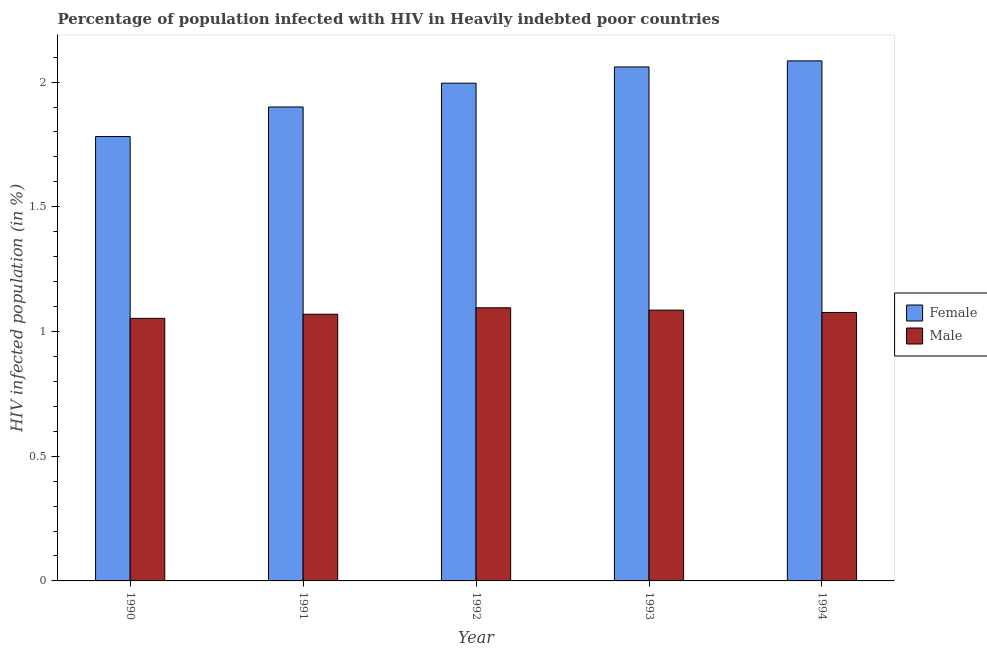How many different coloured bars are there?
Offer a terse response. 2. How many groups of bars are there?
Your response must be concise. 5. How many bars are there on the 1st tick from the left?
Your answer should be very brief. 2. What is the percentage of females who are infected with hiv in 1994?
Offer a terse response. 2.09. Across all years, what is the maximum percentage of males who are infected with hiv?
Your response must be concise. 1.1. Across all years, what is the minimum percentage of males who are infected with hiv?
Keep it short and to the point. 1.05. What is the total percentage of females who are infected with hiv in the graph?
Provide a succinct answer. 9.82. What is the difference between the percentage of males who are infected with hiv in 1991 and that in 1993?
Offer a terse response. -0.02. What is the difference between the percentage of males who are infected with hiv in 1992 and the percentage of females who are infected with hiv in 1994?
Your answer should be very brief. 0.02. What is the average percentage of females who are infected with hiv per year?
Your response must be concise. 1.96. In the year 1993, what is the difference between the percentage of females who are infected with hiv and percentage of males who are infected with hiv?
Provide a short and direct response. 0. In how many years, is the percentage of males who are infected with hiv greater than 1.9 %?
Your answer should be compact. 0. What is the ratio of the percentage of females who are infected with hiv in 1991 to that in 1992?
Ensure brevity in your answer.  0.95. Is the difference between the percentage of males who are infected with hiv in 1991 and 1993 greater than the difference between the percentage of females who are infected with hiv in 1991 and 1993?
Ensure brevity in your answer.  No. What is the difference between the highest and the second highest percentage of males who are infected with hiv?
Provide a succinct answer. 0.01. What is the difference between the highest and the lowest percentage of males who are infected with hiv?
Offer a terse response. 0.04. In how many years, is the percentage of males who are infected with hiv greater than the average percentage of males who are infected with hiv taken over all years?
Keep it short and to the point. 3. Is the sum of the percentage of males who are infected with hiv in 1993 and 1994 greater than the maximum percentage of females who are infected with hiv across all years?
Keep it short and to the point. Yes. What does the 2nd bar from the right in 1992 represents?
Give a very brief answer. Female. Are all the bars in the graph horizontal?
Your answer should be very brief. No. How many years are there in the graph?
Your answer should be very brief. 5. Are the values on the major ticks of Y-axis written in scientific E-notation?
Provide a succinct answer. No. Does the graph contain any zero values?
Offer a terse response. No. Does the graph contain grids?
Offer a very short reply. No. Where does the legend appear in the graph?
Keep it short and to the point. Center right. What is the title of the graph?
Offer a very short reply. Percentage of population infected with HIV in Heavily indebted poor countries. What is the label or title of the Y-axis?
Ensure brevity in your answer.  HIV infected population (in %). What is the HIV infected population (in %) of Female in 1990?
Make the answer very short. 1.78. What is the HIV infected population (in %) in Male in 1990?
Make the answer very short. 1.05. What is the HIV infected population (in %) of Female in 1991?
Keep it short and to the point. 1.9. What is the HIV infected population (in %) of Male in 1991?
Provide a succinct answer. 1.07. What is the HIV infected population (in %) of Female in 1992?
Ensure brevity in your answer.  2. What is the HIV infected population (in %) of Male in 1992?
Provide a short and direct response. 1.1. What is the HIV infected population (in %) of Female in 1993?
Keep it short and to the point. 2.06. What is the HIV infected population (in %) in Male in 1993?
Provide a succinct answer. 1.09. What is the HIV infected population (in %) in Female in 1994?
Offer a very short reply. 2.09. What is the HIV infected population (in %) of Male in 1994?
Offer a very short reply. 1.08. Across all years, what is the maximum HIV infected population (in %) in Female?
Give a very brief answer. 2.09. Across all years, what is the maximum HIV infected population (in %) of Male?
Your answer should be compact. 1.1. Across all years, what is the minimum HIV infected population (in %) in Female?
Ensure brevity in your answer.  1.78. Across all years, what is the minimum HIV infected population (in %) in Male?
Offer a very short reply. 1.05. What is the total HIV infected population (in %) in Female in the graph?
Your answer should be very brief. 9.82. What is the total HIV infected population (in %) in Male in the graph?
Provide a short and direct response. 5.38. What is the difference between the HIV infected population (in %) in Female in 1990 and that in 1991?
Your answer should be very brief. -0.12. What is the difference between the HIV infected population (in %) in Male in 1990 and that in 1991?
Offer a terse response. -0.02. What is the difference between the HIV infected population (in %) of Female in 1990 and that in 1992?
Provide a short and direct response. -0.21. What is the difference between the HIV infected population (in %) of Male in 1990 and that in 1992?
Offer a very short reply. -0.04. What is the difference between the HIV infected population (in %) in Female in 1990 and that in 1993?
Offer a terse response. -0.28. What is the difference between the HIV infected population (in %) of Male in 1990 and that in 1993?
Ensure brevity in your answer.  -0.03. What is the difference between the HIV infected population (in %) in Female in 1990 and that in 1994?
Your answer should be very brief. -0.3. What is the difference between the HIV infected population (in %) in Male in 1990 and that in 1994?
Your answer should be compact. -0.02. What is the difference between the HIV infected population (in %) of Female in 1991 and that in 1992?
Offer a very short reply. -0.1. What is the difference between the HIV infected population (in %) of Male in 1991 and that in 1992?
Your response must be concise. -0.03. What is the difference between the HIV infected population (in %) in Female in 1991 and that in 1993?
Ensure brevity in your answer.  -0.16. What is the difference between the HIV infected population (in %) of Male in 1991 and that in 1993?
Offer a very short reply. -0.02. What is the difference between the HIV infected population (in %) in Female in 1991 and that in 1994?
Ensure brevity in your answer.  -0.18. What is the difference between the HIV infected population (in %) in Male in 1991 and that in 1994?
Your response must be concise. -0.01. What is the difference between the HIV infected population (in %) of Female in 1992 and that in 1993?
Offer a very short reply. -0.07. What is the difference between the HIV infected population (in %) in Male in 1992 and that in 1993?
Offer a terse response. 0.01. What is the difference between the HIV infected population (in %) in Female in 1992 and that in 1994?
Provide a succinct answer. -0.09. What is the difference between the HIV infected population (in %) of Male in 1992 and that in 1994?
Ensure brevity in your answer.  0.02. What is the difference between the HIV infected population (in %) of Female in 1993 and that in 1994?
Ensure brevity in your answer.  -0.02. What is the difference between the HIV infected population (in %) in Male in 1993 and that in 1994?
Provide a succinct answer. 0.01. What is the difference between the HIV infected population (in %) of Female in 1990 and the HIV infected population (in %) of Male in 1991?
Provide a succinct answer. 0.71. What is the difference between the HIV infected population (in %) in Female in 1990 and the HIV infected population (in %) in Male in 1992?
Your answer should be compact. 0.69. What is the difference between the HIV infected population (in %) in Female in 1990 and the HIV infected population (in %) in Male in 1993?
Offer a terse response. 0.7. What is the difference between the HIV infected population (in %) in Female in 1990 and the HIV infected population (in %) in Male in 1994?
Give a very brief answer. 0.71. What is the difference between the HIV infected population (in %) of Female in 1991 and the HIV infected population (in %) of Male in 1992?
Your answer should be very brief. 0.81. What is the difference between the HIV infected population (in %) in Female in 1991 and the HIV infected population (in %) in Male in 1993?
Make the answer very short. 0.81. What is the difference between the HIV infected population (in %) of Female in 1991 and the HIV infected population (in %) of Male in 1994?
Ensure brevity in your answer.  0.82. What is the difference between the HIV infected population (in %) in Female in 1992 and the HIV infected population (in %) in Male in 1993?
Give a very brief answer. 0.91. What is the difference between the HIV infected population (in %) of Female in 1992 and the HIV infected population (in %) of Male in 1994?
Your response must be concise. 0.92. What is the difference between the HIV infected population (in %) of Female in 1993 and the HIV infected population (in %) of Male in 1994?
Your answer should be very brief. 0.98. What is the average HIV infected population (in %) in Female per year?
Your answer should be very brief. 1.96. What is the average HIV infected population (in %) in Male per year?
Offer a terse response. 1.08. In the year 1990, what is the difference between the HIV infected population (in %) of Female and HIV infected population (in %) of Male?
Ensure brevity in your answer.  0.73. In the year 1991, what is the difference between the HIV infected population (in %) in Female and HIV infected population (in %) in Male?
Your answer should be compact. 0.83. In the year 1992, what is the difference between the HIV infected population (in %) of Female and HIV infected population (in %) of Male?
Provide a short and direct response. 0.9. In the year 1994, what is the difference between the HIV infected population (in %) of Female and HIV infected population (in %) of Male?
Your response must be concise. 1.01. What is the ratio of the HIV infected population (in %) of Female in 1990 to that in 1991?
Your answer should be compact. 0.94. What is the ratio of the HIV infected population (in %) in Male in 1990 to that in 1991?
Your response must be concise. 0.98. What is the ratio of the HIV infected population (in %) of Female in 1990 to that in 1992?
Your answer should be very brief. 0.89. What is the ratio of the HIV infected population (in %) in Male in 1990 to that in 1992?
Give a very brief answer. 0.96. What is the ratio of the HIV infected population (in %) in Female in 1990 to that in 1993?
Give a very brief answer. 0.86. What is the ratio of the HIV infected population (in %) of Male in 1990 to that in 1993?
Offer a terse response. 0.97. What is the ratio of the HIV infected population (in %) of Female in 1990 to that in 1994?
Offer a terse response. 0.85. What is the ratio of the HIV infected population (in %) of Male in 1990 to that in 1994?
Your answer should be very brief. 0.98. What is the ratio of the HIV infected population (in %) in Female in 1991 to that in 1992?
Your answer should be compact. 0.95. What is the ratio of the HIV infected population (in %) in Male in 1991 to that in 1992?
Your response must be concise. 0.98. What is the ratio of the HIV infected population (in %) of Female in 1991 to that in 1993?
Your answer should be very brief. 0.92. What is the ratio of the HIV infected population (in %) of Female in 1991 to that in 1994?
Make the answer very short. 0.91. What is the ratio of the HIV infected population (in %) of Male in 1991 to that in 1994?
Offer a very short reply. 0.99. What is the ratio of the HIV infected population (in %) in Female in 1992 to that in 1993?
Keep it short and to the point. 0.97. What is the ratio of the HIV infected population (in %) of Male in 1992 to that in 1993?
Make the answer very short. 1.01. What is the ratio of the HIV infected population (in %) of Female in 1992 to that in 1994?
Provide a short and direct response. 0.96. What is the ratio of the HIV infected population (in %) of Male in 1992 to that in 1994?
Provide a succinct answer. 1.02. What is the ratio of the HIV infected population (in %) in Female in 1993 to that in 1994?
Your answer should be very brief. 0.99. What is the ratio of the HIV infected population (in %) in Male in 1993 to that in 1994?
Provide a short and direct response. 1.01. What is the difference between the highest and the second highest HIV infected population (in %) in Female?
Offer a very short reply. 0.02. What is the difference between the highest and the second highest HIV infected population (in %) in Male?
Provide a succinct answer. 0.01. What is the difference between the highest and the lowest HIV infected population (in %) of Female?
Provide a succinct answer. 0.3. What is the difference between the highest and the lowest HIV infected population (in %) in Male?
Offer a terse response. 0.04. 